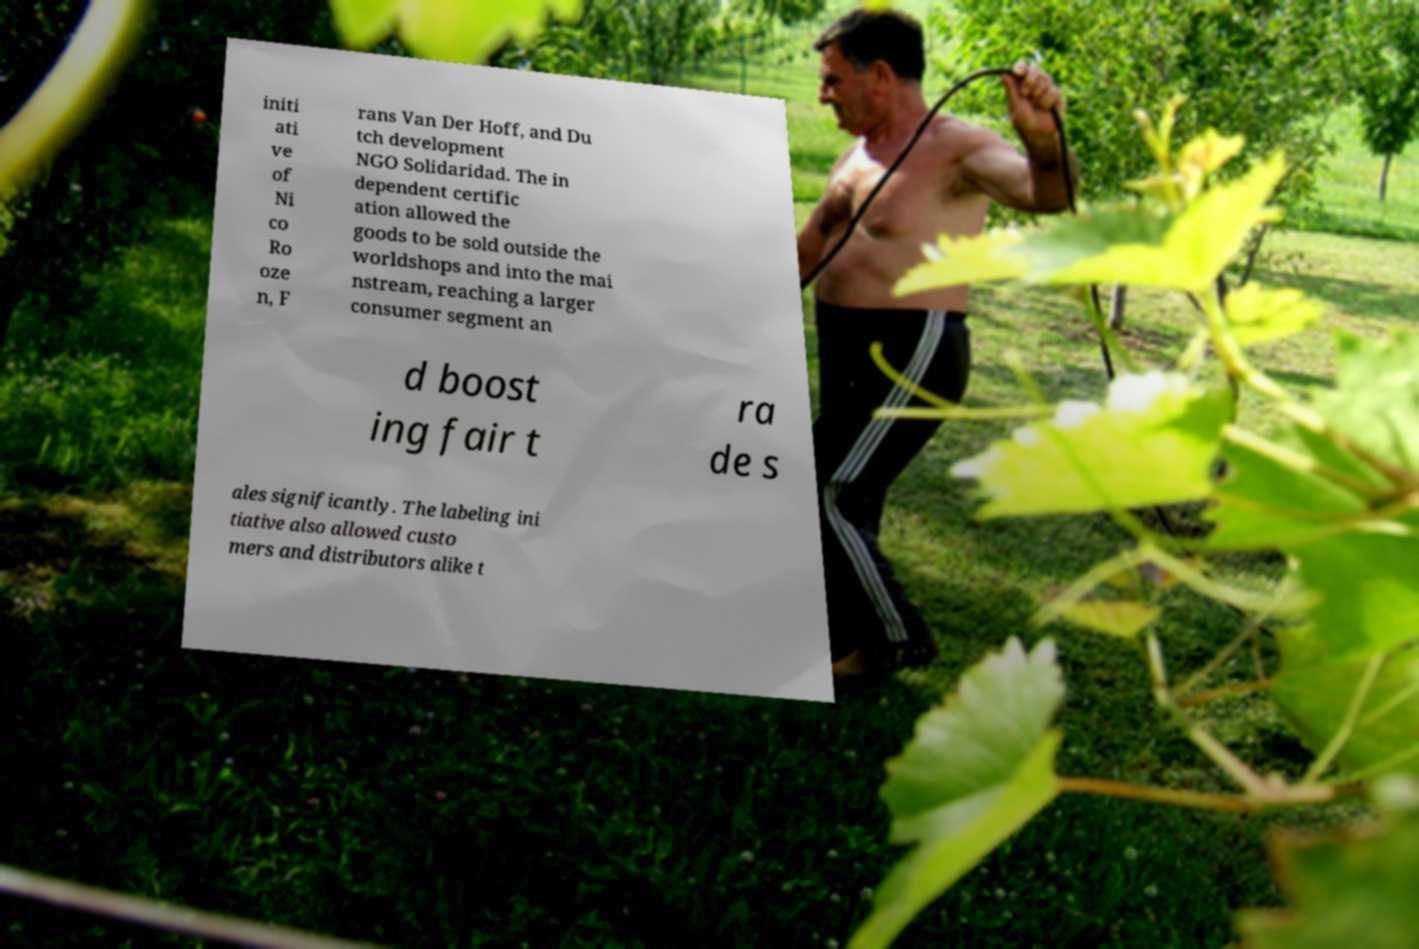I need the written content from this picture converted into text. Can you do that? initi ati ve of Ni co Ro oze n, F rans Van Der Hoff, and Du tch development NGO Solidaridad. The in dependent certific ation allowed the goods to be sold outside the worldshops and into the mai nstream, reaching a larger consumer segment an d boost ing fair t ra de s ales significantly. The labeling ini tiative also allowed custo mers and distributors alike t 